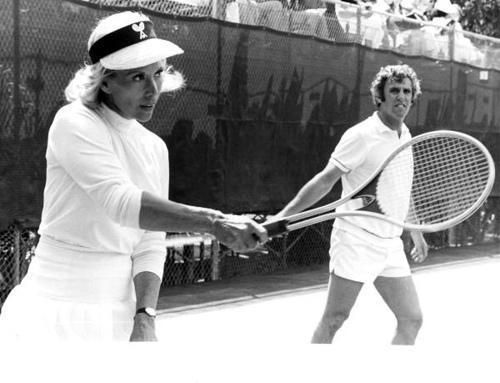How many people are in the photo?
Give a very brief answer. 2. How many facets does this sink have?
Give a very brief answer. 0. 